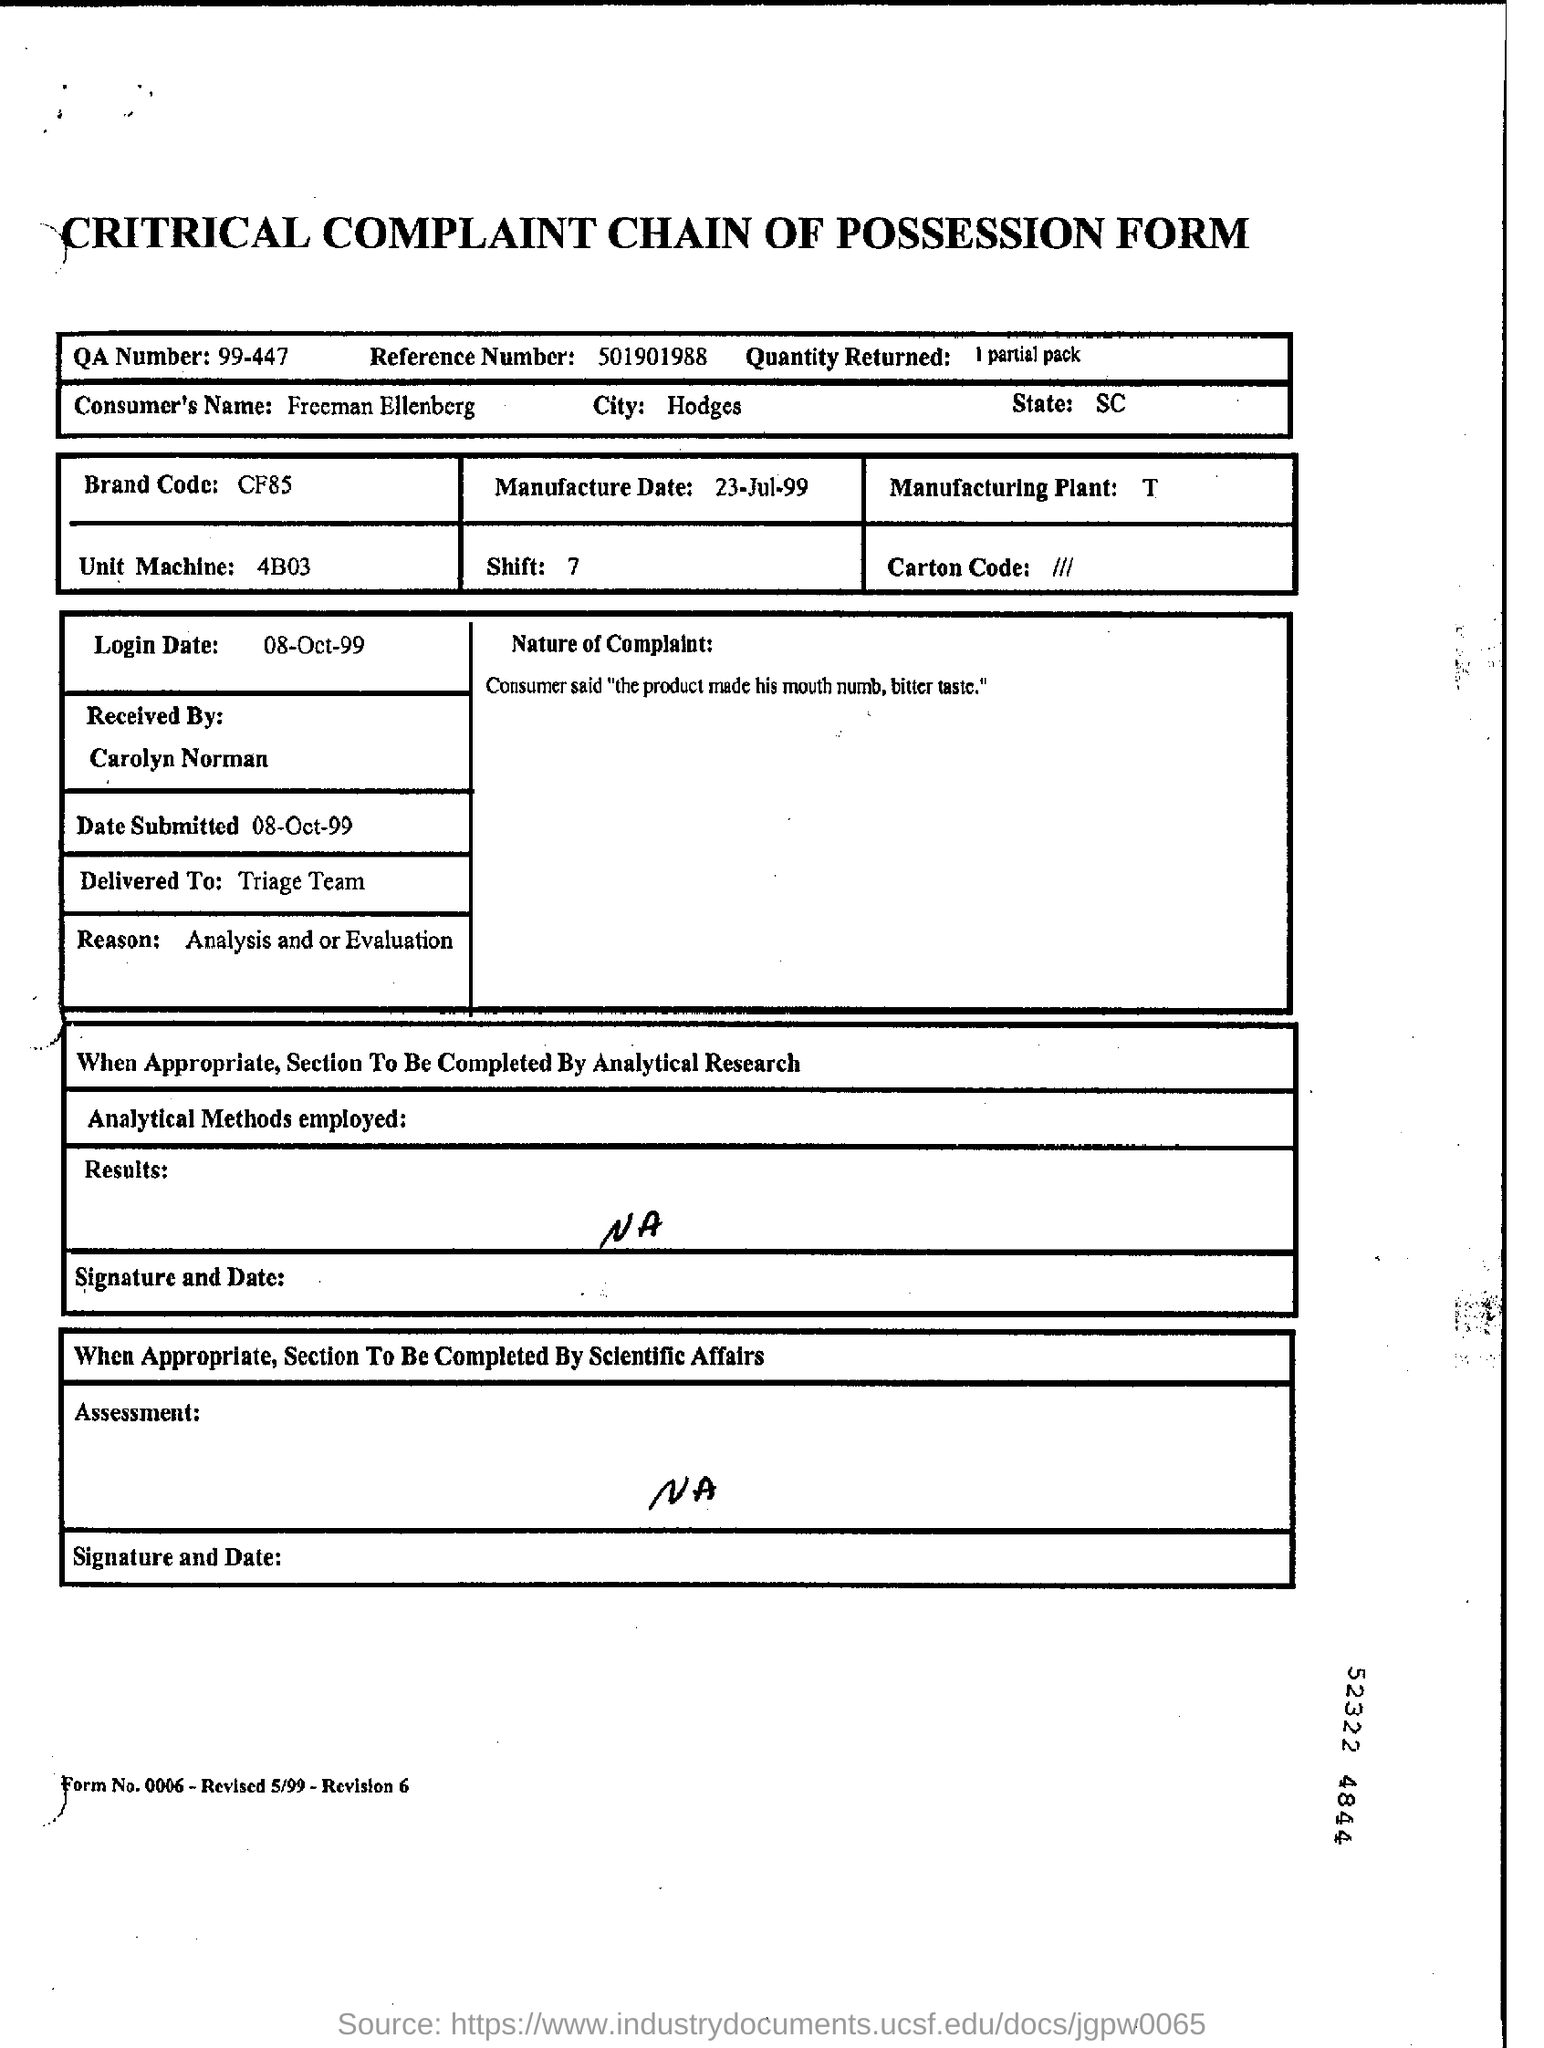Mention a couple of crucial points in this snapshot. The reference number given is 501901988. The brand code is CF85. The consumer's name is Freeman Ellenberg. The unit machine was 4B03. The quantity returned was 1 partial pack. 